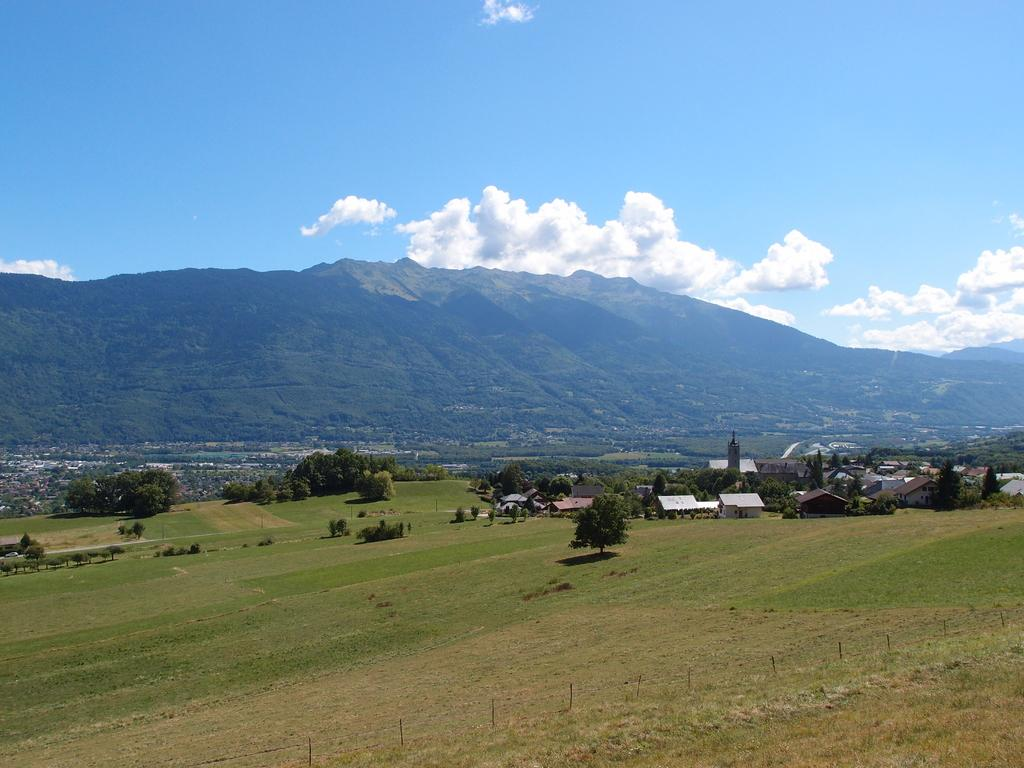What type of surface can be seen in the image? There is a grass surface in the image. What other natural elements are present in the image? There are trees in the image. Are there any man-made structures visible? Yes, there are houses in the image. What is the terrain like in the image? There is a hill covered with grass in the image. What is visible in the sky in the image? The sky is visible in the image, and clouds are present. Can you tell me how many wires are connected to the trees in the image? There are no wires connected to the trees in the image. What type of swimming activity is taking place in the image? There is no swimming activity present in the image. 